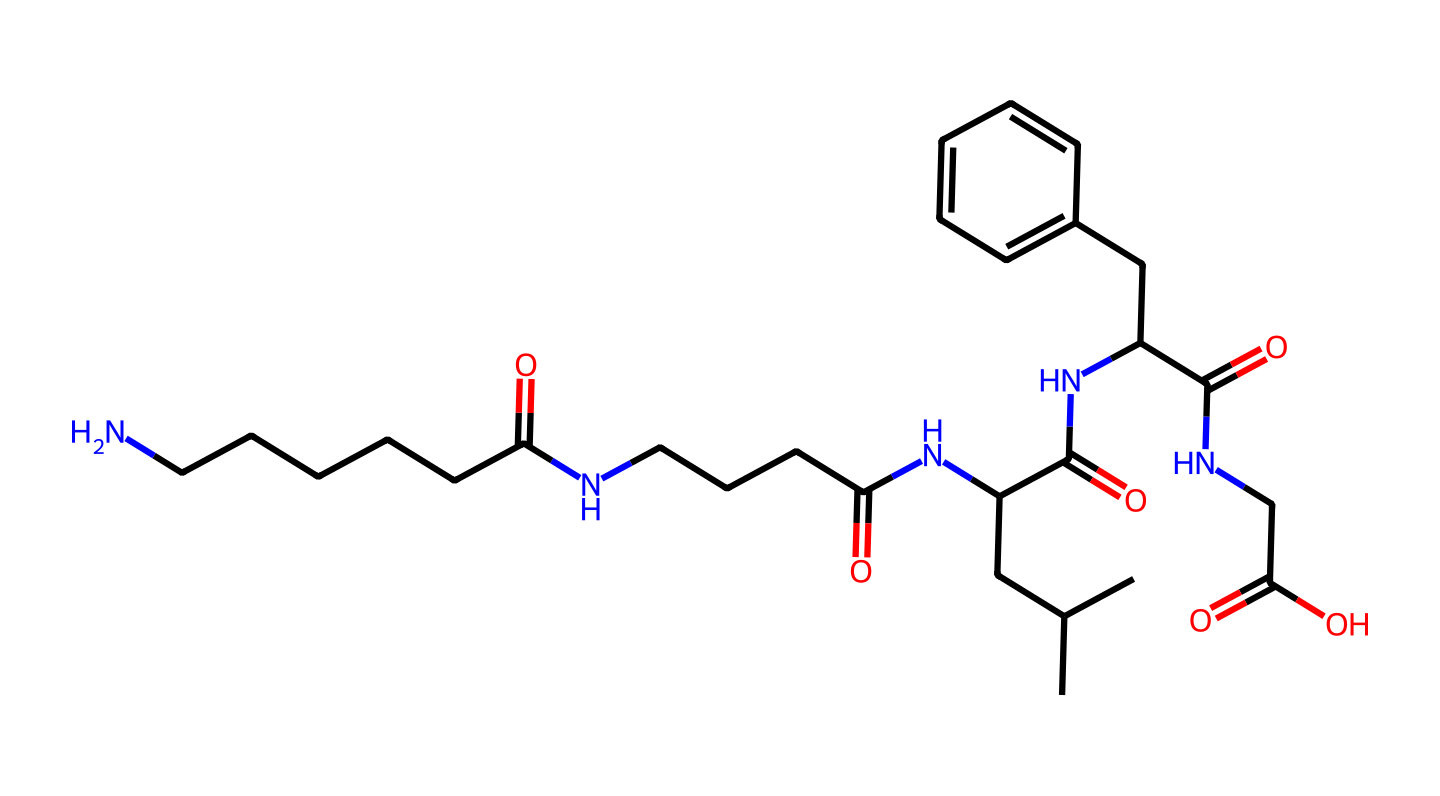What is the main functional group present in this molecule? The structure contains multiple amide bonds, indicated by the carbonyl (C=O) and nitrogen (N) groups in a repeating pattern, which is characteristic of amides.
Answer: amide How many carbon atoms are present in this molecule? By counting the carbon (C) atoms in the provided SMILES notation, there are a total of 21 carbon atoms present in the structure.
Answer: 21 What type of polymer is represented by this chemical structure? The chemical structure displays features of a synthetic polymer known as nylon due to its repeating amide linkages and it being a polyamide.
Answer: nylon What types of atoms (besides carbon) are found in this molecule? An examination of the SMILES structure reveals the presence of hydrogen (H), nitrogen (N), and oxygen (O) atoms, indicating the molecular composition beyond just carbon.
Answer: hydrogen, nitrogen, oxygen How many amide bonds are present in this molecule? By analyzing the structure, there are multiple connections between carbon and nitrogen with carbonyls, indicating the presence of five amide bonds in total.
Answer: 5 